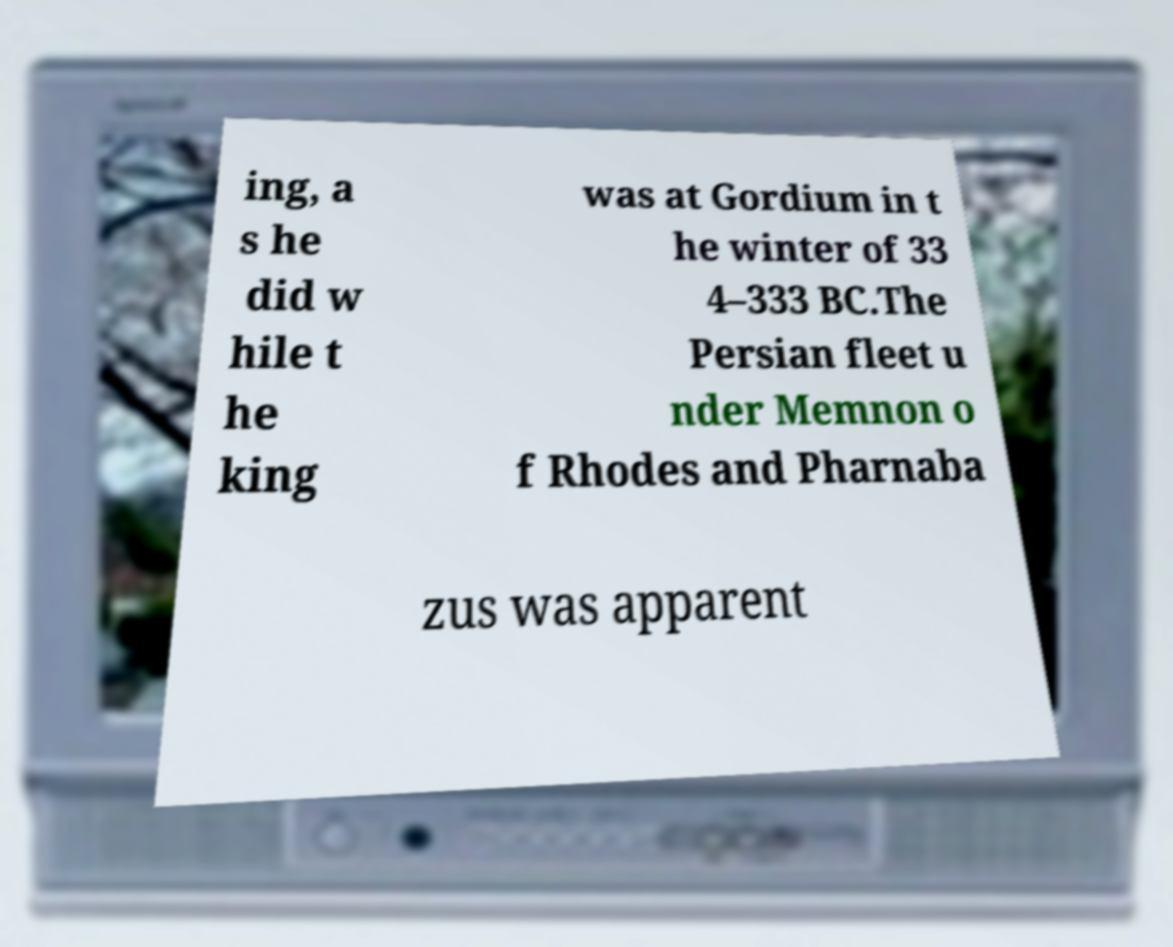Could you extract and type out the text from this image? ing, a s he did w hile t he king was at Gordium in t he winter of 33 4–333 BC.The Persian fleet u nder Memnon o f Rhodes and Pharnaba zus was apparent 